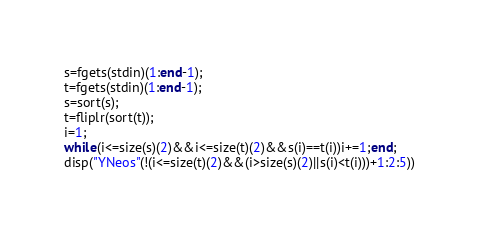<code> <loc_0><loc_0><loc_500><loc_500><_Octave_>s=fgets(stdin)(1:end-1);
t=fgets(stdin)(1:end-1);
s=sort(s);
t=fliplr(sort(t));
i=1;
while(i<=size(s)(2)&&i<=size(t)(2)&&s(i)==t(i))i+=1;end;
disp("YNeos"(!(i<=size(t)(2)&&(i>size(s)(2)||s(i)<t(i)))+1:2:5))
</code> 